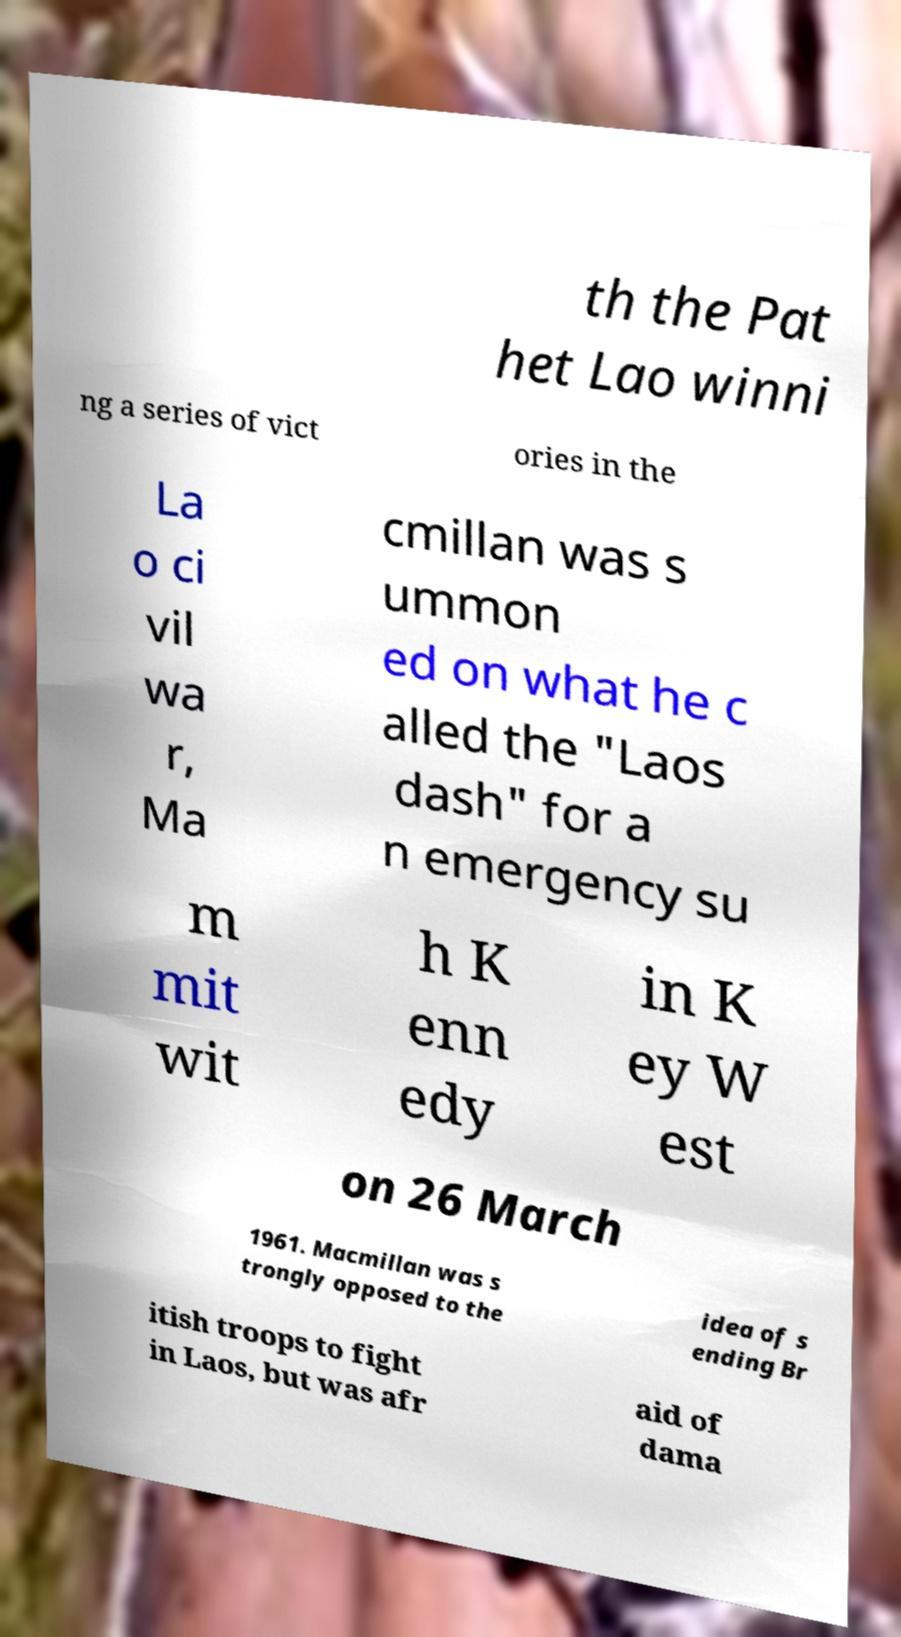What messages or text are displayed in this image? I need them in a readable, typed format. th the Pat het Lao winni ng a series of vict ories in the La o ci vil wa r, Ma cmillan was s ummon ed on what he c alled the "Laos dash" for a n emergency su m mit wit h K enn edy in K ey W est on 26 March 1961. Macmillan was s trongly opposed to the idea of s ending Br itish troops to fight in Laos, but was afr aid of dama 